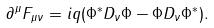<formula> <loc_0><loc_0><loc_500><loc_500>\partial ^ { \mu } F _ { \mu \nu } = i q ( \Phi ^ { \ast } D _ { \nu } \Phi - \Phi D _ { \nu } \Phi ^ { \ast } ) .</formula> 